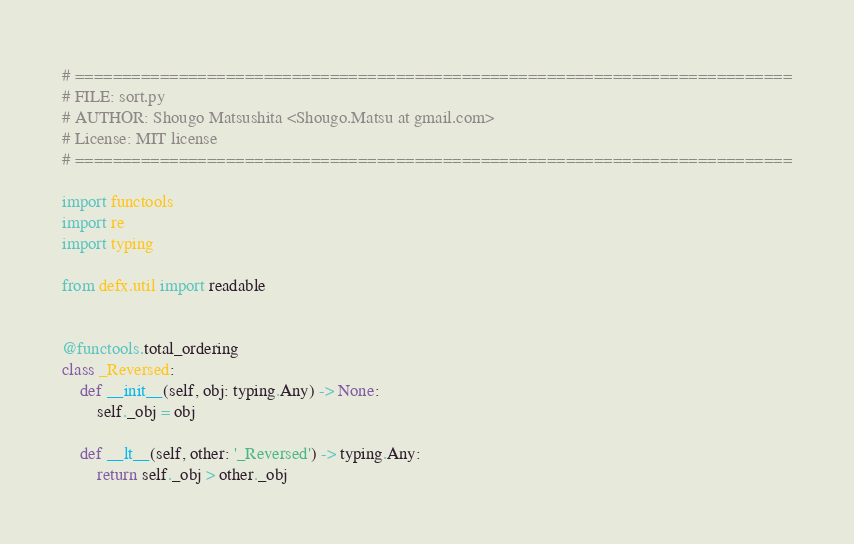<code> <loc_0><loc_0><loc_500><loc_500><_Python_># ============================================================================
# FILE: sort.py
# AUTHOR: Shougo Matsushita <Shougo.Matsu at gmail.com>
# License: MIT license
# ============================================================================

import functools
import re
import typing

from defx.util import readable


@functools.total_ordering
class _Reversed:
    def __init__(self, obj: typing.Any) -> None:
        self._obj = obj

    def __lt__(self, other: '_Reversed') -> typing.Any:
        return self._obj > other._obj
</code> 